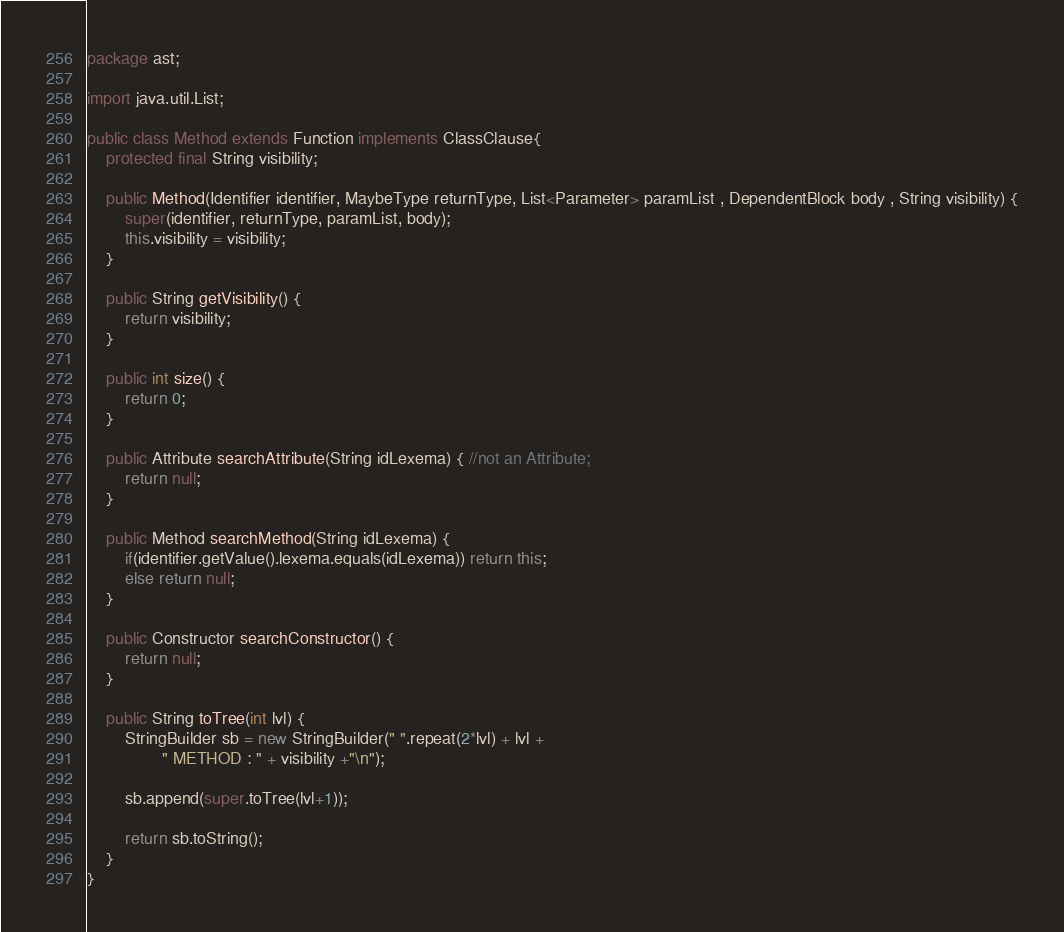<code> <loc_0><loc_0><loc_500><loc_500><_Java_>package ast;

import java.util.List;

public class Method extends Function implements ClassClause{
    protected final String visibility;

	public Method(Identifier identifier, MaybeType returnType, List<Parameter> paramList , DependentBlock body , String visibility) {
		super(identifier, returnType, paramList, body);
		this.visibility = visibility;
	}
    
	public String getVisibility() {
		return visibility;
	}
    
	public int size() {
		return 0;
	}
	
	public Attribute searchAttribute(String idLexema) { //not an Attribute;
		return null;
	}
	
	public Method searchMethod(String idLexema) {
		if(identifier.getValue().lexema.equals(idLexema)) return this;
		else return null;
	}
	
	public Constructor searchConstructor() {
		return null;
	}
	
	public String toTree(int lvl) {
		StringBuilder sb = new StringBuilder(" ".repeat(2*lvl) + lvl +
				" METHOD : " + visibility +"\n");
		
		sb.append(super.toTree(lvl+1));
		
		return sb.toString();
	}
}
</code> 